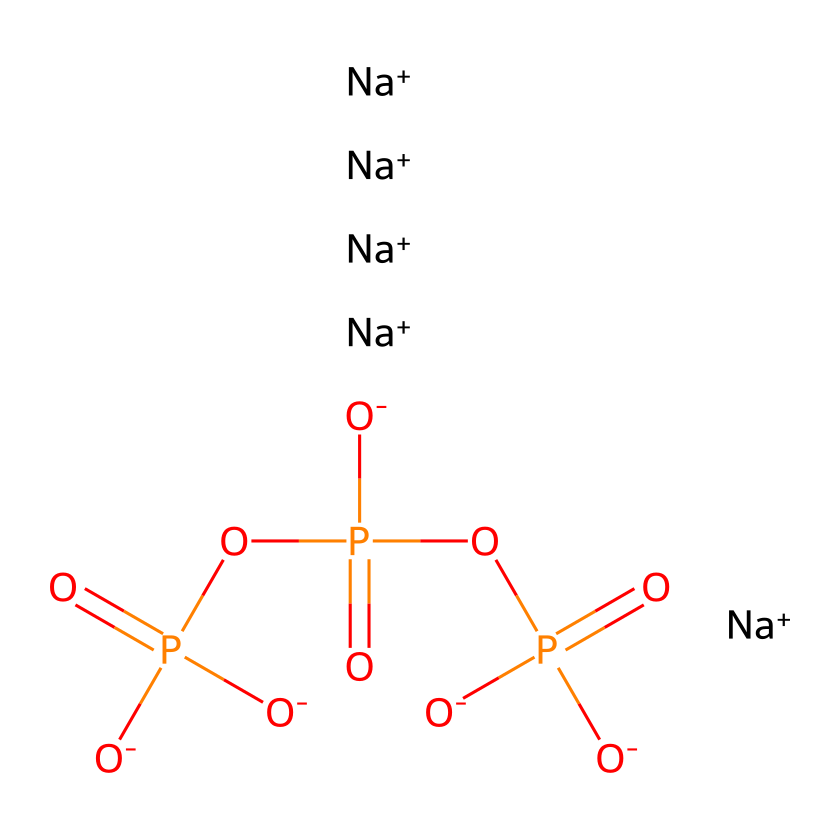What type of ions are present in this chemical? The structure shows the presence of sodium ions, indicated by [Na+]. There are five sodium ions in total.
Answer: sodium How many phosphorus atoms are there in the molecule? The structure reveals three phosphorus atoms, highlighted in the core structure of the molecule, connected to the surrounding oxygen atoms.
Answer: three What is the total number of oxygen atoms in this chemical? Counting the oxygen atoms in the structure, there are a total of six oxygen atoms associated with the phosphorus atoms and within the overall molecular framework.
Answer: six Which functional group is primarily responsible for the potential eutrophication effect? The phosphate groups (indicated by the P=O and O-P bonds) are responsible for phosphate-based eutrophication in coastal waters, leading to nutrient overload.
Answer: phosphate What negative environmental impact can the builders in detergents cause? The phosphate builders can lead to algal blooms in coastal waters when they increase nutrient levels, resulting in eutrophication which depletes oxygen in water bodies.
Answer: eutrophication What type of chemical is this phosphorous compound classified as? This molecule is classified as a phosphate ester, characterized by its structure involving phosphorus and oxygen.
Answer: phosphate ester 